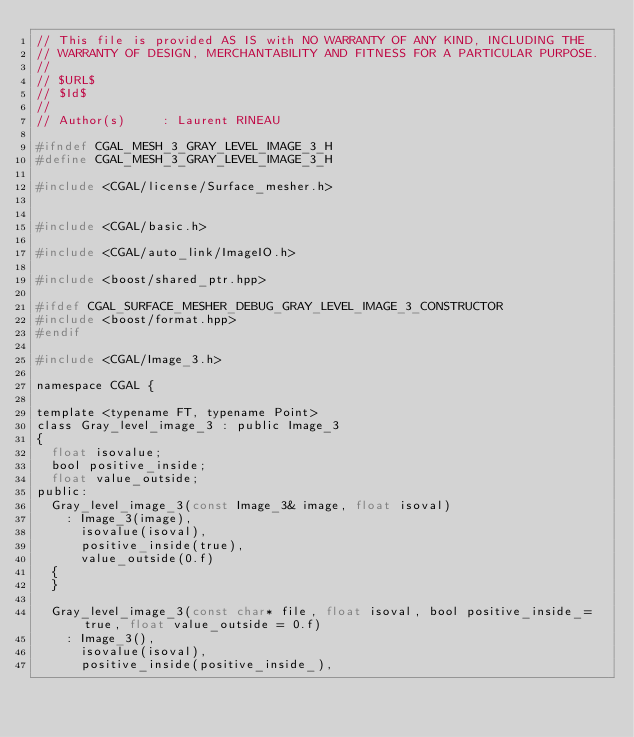Convert code to text. <code><loc_0><loc_0><loc_500><loc_500><_C_>// This file is provided AS IS with NO WARRANTY OF ANY KIND, INCLUDING THE
// WARRANTY OF DESIGN, MERCHANTABILITY AND FITNESS FOR A PARTICULAR PURPOSE.
//
// $URL$
// $Id$
//
// Author(s)     : Laurent RINEAU

#ifndef CGAL_MESH_3_GRAY_LEVEL_IMAGE_3_H
#define CGAL_MESH_3_GRAY_LEVEL_IMAGE_3_H

#include <CGAL/license/Surface_mesher.h>


#include <CGAL/basic.h>

#include <CGAL/auto_link/ImageIO.h>

#include <boost/shared_ptr.hpp>

#ifdef CGAL_SURFACE_MESHER_DEBUG_GRAY_LEVEL_IMAGE_3_CONSTRUCTOR
#include <boost/format.hpp>
#endif

#include <CGAL/Image_3.h>

namespace CGAL {

template <typename FT, typename Point>
class Gray_level_image_3 : public Image_3
{
  float isovalue;
  bool positive_inside;
  float value_outside;
public:
  Gray_level_image_3(const Image_3& image, float isoval) 
    : Image_3(image),
      isovalue(isoval),
      positive_inside(true),
      value_outside(0.f)
  {
  }

  Gray_level_image_3(const char* file, float isoval, bool positive_inside_=true, float value_outside = 0.f)
    : Image_3(),
      isovalue(isoval),
      positive_inside(positive_inside_),</code> 